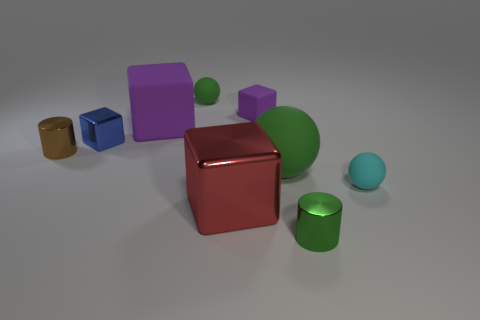How would you interpret the scene presented in this image? The image seems to be a carefully arranged composition of various colored geometric shapes, possibly intended to represent a study in color contrast, spatial relationships, and the play of light on different surfaces. It lends itself to interpretations related to balance, diversity, or even an abstract depiction of a playful, yet orderly, environment. 